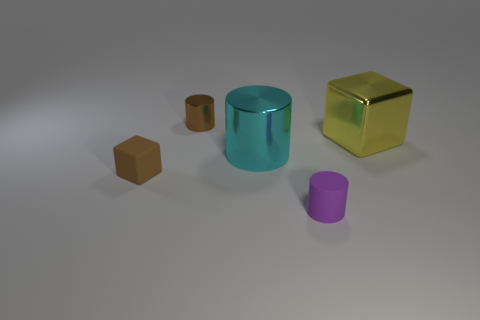What time of day does the lighting in the image suggest? The lighting in the image is neutral and diffuse, suggesting an interior setting with artificial light rather than natural sunlight, making it difficult to determine the time of day. 